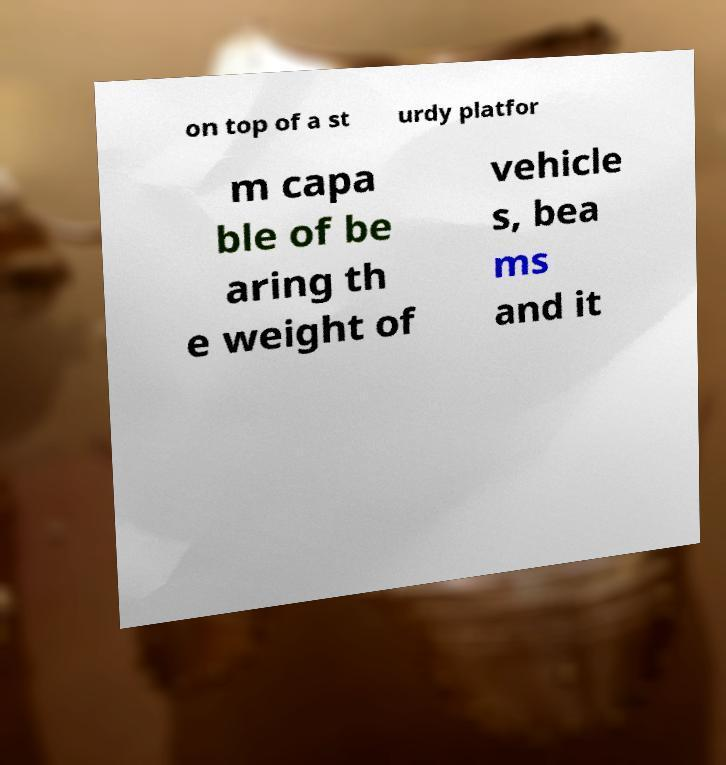Could you assist in decoding the text presented in this image and type it out clearly? on top of a st urdy platfor m capa ble of be aring th e weight of vehicle s, bea ms and it 